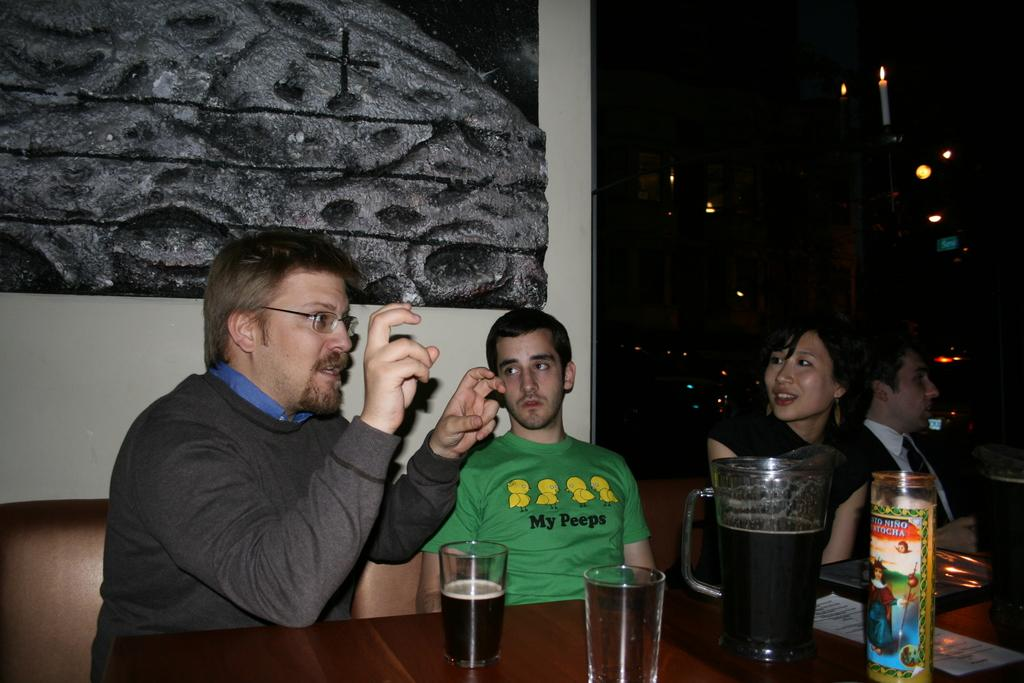<image>
Share a concise interpretation of the image provided. A young man wears a green t-shirt with My Peeps on it. 